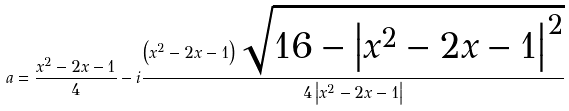Convert formula to latex. <formula><loc_0><loc_0><loc_500><loc_500>a = \frac { x ^ { 2 } - 2 x - 1 } { 4 } - i \frac { \left ( x ^ { 2 } - 2 x - 1 \right ) \sqrt { 1 6 - \left | x ^ { 2 } - 2 x - 1 \right | ^ { 2 } } } { 4 \left | x ^ { 2 } - 2 x - 1 \right | }</formula> 